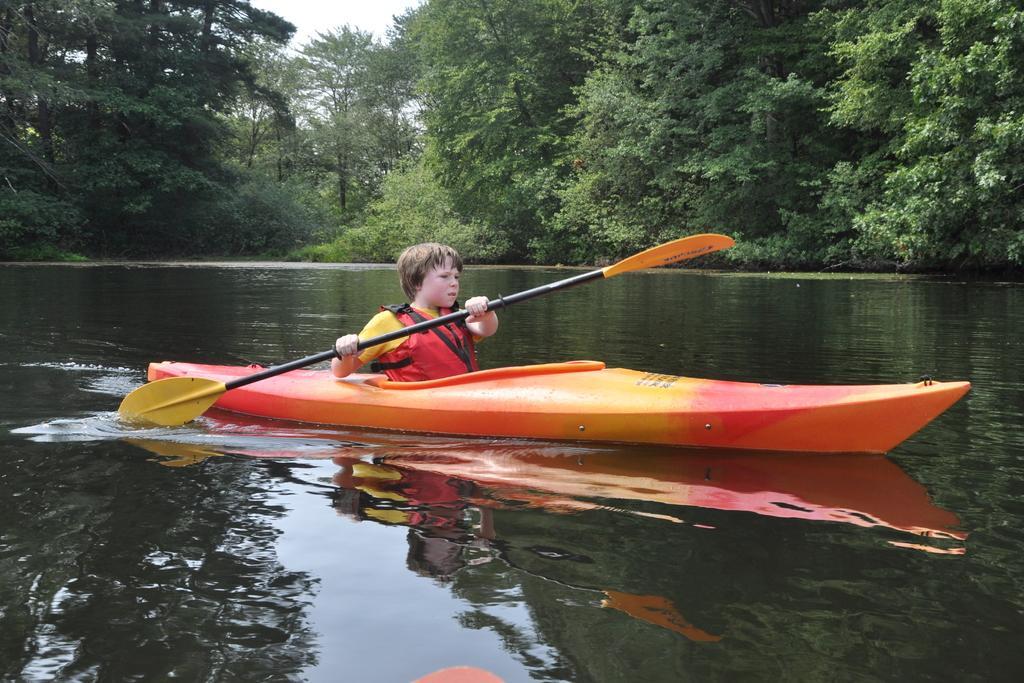Could you give a brief overview of what you see in this image? Above this water there is a boat. This person is holding a paddle. Background we can see trees. 